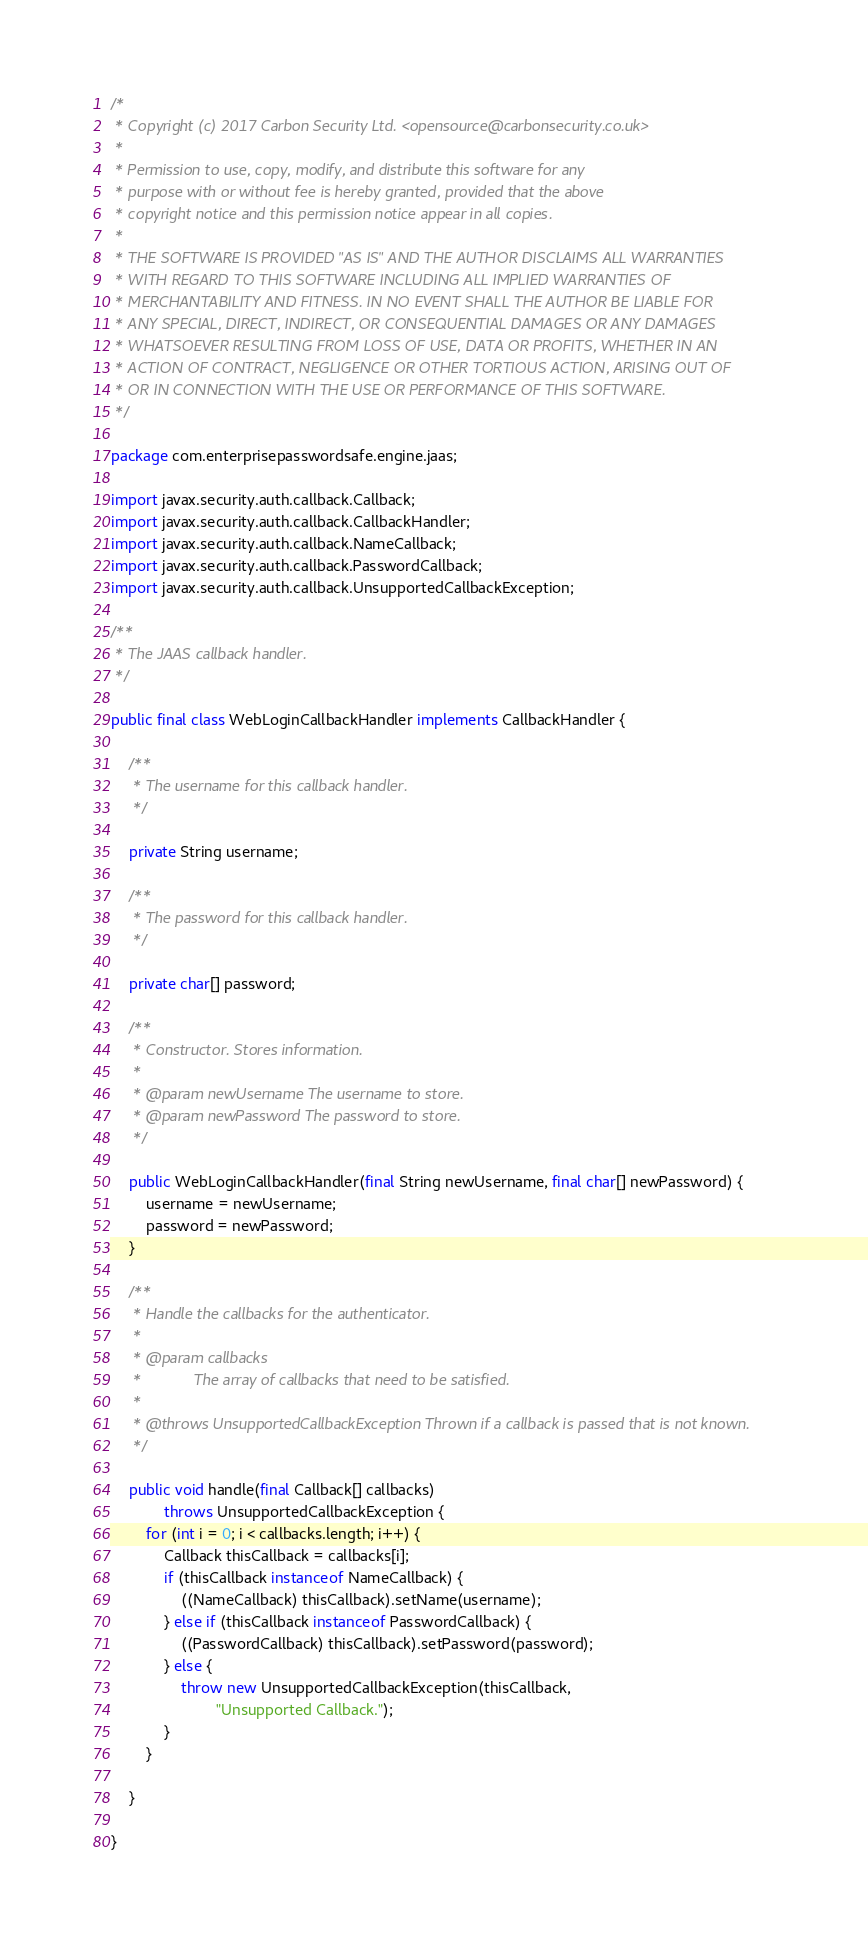<code> <loc_0><loc_0><loc_500><loc_500><_Java_>/*
 * Copyright (c) 2017 Carbon Security Ltd. <opensource@carbonsecurity.co.uk>
 *
 * Permission to use, copy, modify, and distribute this software for any
 * purpose with or without fee is hereby granted, provided that the above
 * copyright notice and this permission notice appear in all copies.
 *
 * THE SOFTWARE IS PROVIDED "AS IS" AND THE AUTHOR DISCLAIMS ALL WARRANTIES
 * WITH REGARD TO THIS SOFTWARE INCLUDING ALL IMPLIED WARRANTIES OF
 * MERCHANTABILITY AND FITNESS. IN NO EVENT SHALL THE AUTHOR BE LIABLE FOR
 * ANY SPECIAL, DIRECT, INDIRECT, OR CONSEQUENTIAL DAMAGES OR ANY DAMAGES
 * WHATSOEVER RESULTING FROM LOSS OF USE, DATA OR PROFITS, WHETHER IN AN
 * ACTION OF CONTRACT, NEGLIGENCE OR OTHER TORTIOUS ACTION, ARISING OUT OF
 * OR IN CONNECTION WITH THE USE OR PERFORMANCE OF THIS SOFTWARE.
 */

package com.enterprisepasswordsafe.engine.jaas;

import javax.security.auth.callback.Callback;
import javax.security.auth.callback.CallbackHandler;
import javax.security.auth.callback.NameCallback;
import javax.security.auth.callback.PasswordCallback;
import javax.security.auth.callback.UnsupportedCallbackException;

/**
 * The JAAS callback handler.
 */

public final class WebLoginCallbackHandler implements CallbackHandler {

    /**
     * The username for this callback handler.
     */

    private String username;

    /**
     * The password for this callback handler.
     */

    private char[] password;

    /**
     * Constructor. Stores information.
     *
     * @param newUsername The username to store.
     * @param newPassword The password to store.
     */

    public WebLoginCallbackHandler(final String newUsername, final char[] newPassword) {
        username = newUsername;
        password = newPassword;
    }

    /**
     * Handle the callbacks for the authenticator.
     *
     * @param callbacks
     *            The array of callbacks that need to be satisfied.
     *
     * @throws UnsupportedCallbackException Thrown if a callback is passed that is not known.
     */

    public void handle(final Callback[] callbacks)
            throws UnsupportedCallbackException {
        for (int i = 0; i < callbacks.length; i++) {
            Callback thisCallback = callbacks[i];
            if (thisCallback instanceof NameCallback) {
                ((NameCallback) thisCallback).setName(username);
            } else if (thisCallback instanceof PasswordCallback) {
                ((PasswordCallback) thisCallback).setPassword(password);
            } else {
                throw new UnsupportedCallbackException(thisCallback,
                        "Unsupported Callback.");
            }
        }

    }

}
</code> 